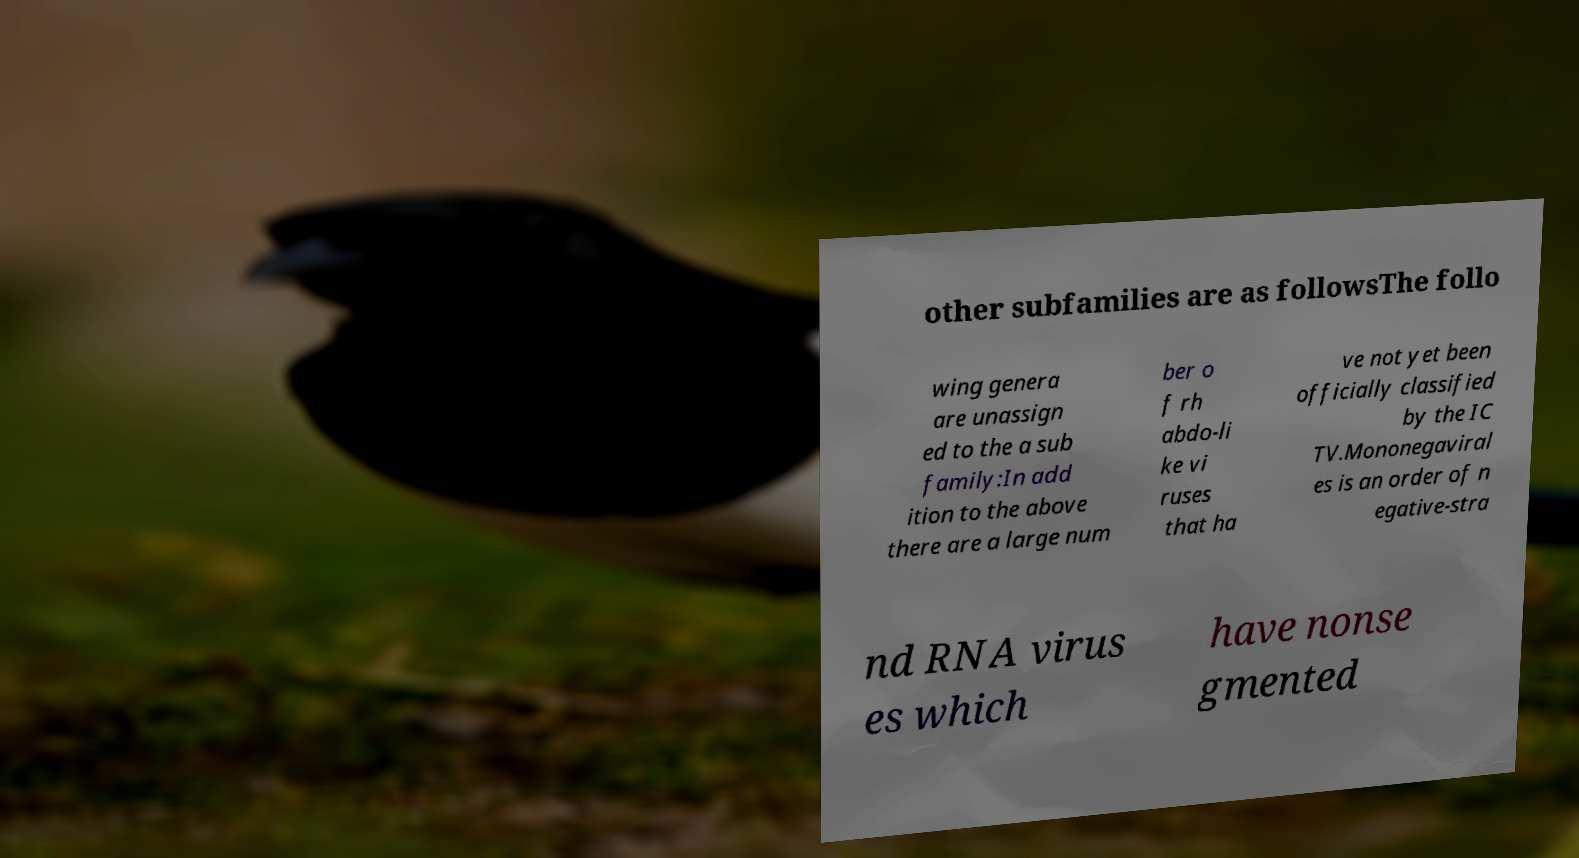Can you accurately transcribe the text from the provided image for me? other subfamilies are as followsThe follo wing genera are unassign ed to the a sub family:In add ition to the above there are a large num ber o f rh abdo-li ke vi ruses that ha ve not yet been officially classified by the IC TV.Mononegaviral es is an order of n egative-stra nd RNA virus es which have nonse gmented 